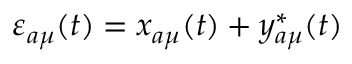<formula> <loc_0><loc_0><loc_500><loc_500>\varepsilon _ { a \mu } ( t ) = x _ { a \mu } ( t ) + y _ { a \mu } ^ { * } ( t )</formula> 